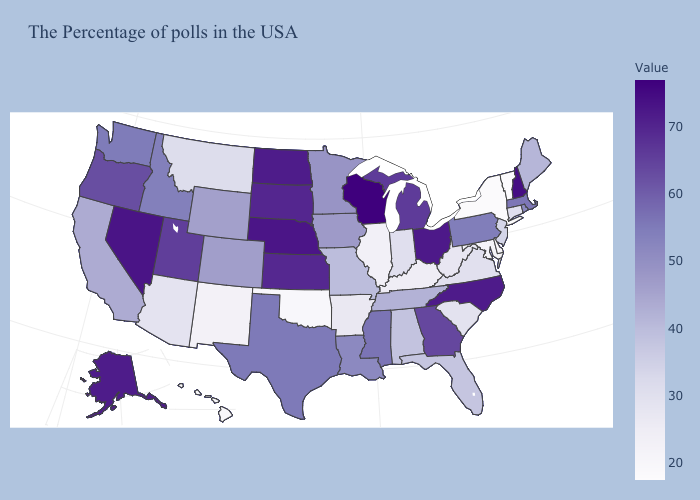Among the states that border Georgia , which have the highest value?
Concise answer only. North Carolina. Does Tennessee have the highest value in the USA?
Short answer required. No. Which states have the highest value in the USA?
Concise answer only. Wisconsin. Does Ohio have a higher value than Missouri?
Keep it brief. Yes. Among the states that border Illinois , which have the lowest value?
Write a very short answer. Kentucky. 